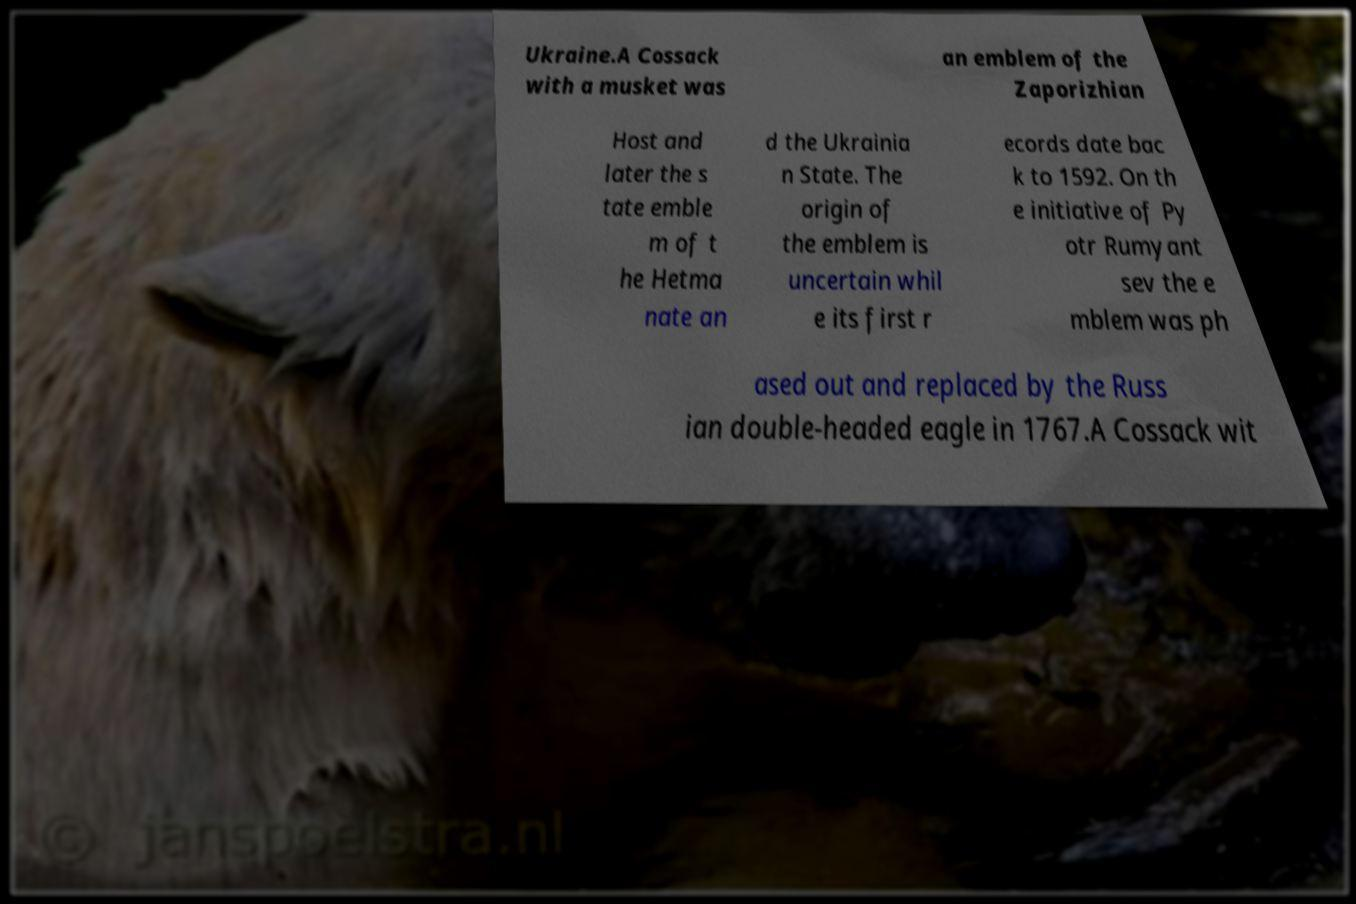Could you assist in decoding the text presented in this image and type it out clearly? Ukraine.A Cossack with a musket was an emblem of the Zaporizhian Host and later the s tate emble m of t he Hetma nate an d the Ukrainia n State. The origin of the emblem is uncertain whil e its first r ecords date bac k to 1592. On th e initiative of Py otr Rumyant sev the e mblem was ph ased out and replaced by the Russ ian double-headed eagle in 1767.A Cossack wit 